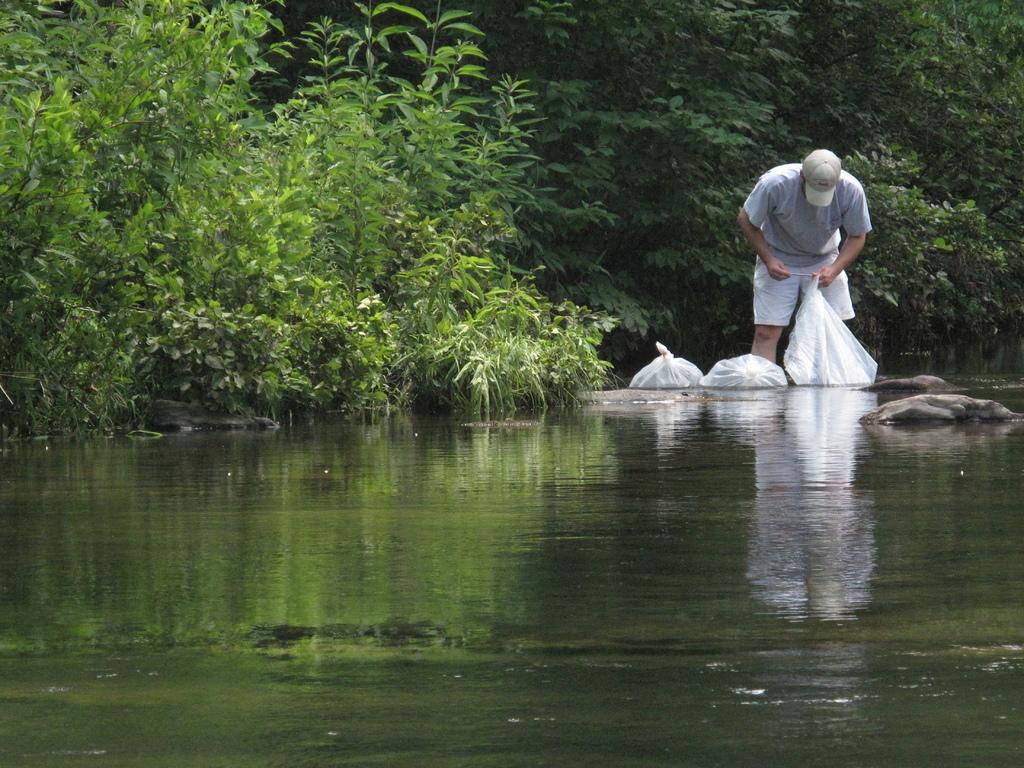Please provide a concise description of this image. In this image we can see a man standing holding a cover. We can also see some covers beside him, some stones, a water body, some plants and a group of trees. 